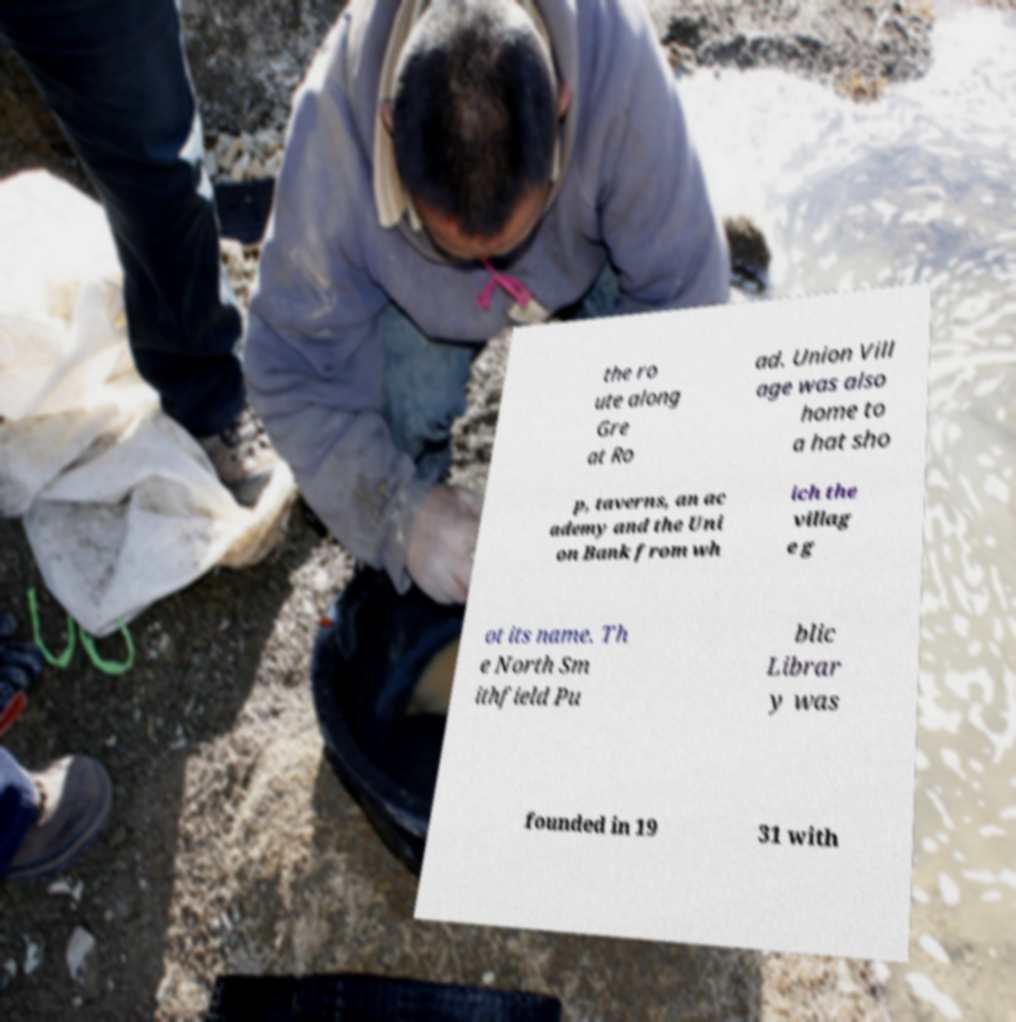Can you accurately transcribe the text from the provided image for me? the ro ute along Gre at Ro ad. Union Vill age was also home to a hat sho p, taverns, an ac ademy and the Uni on Bank from wh ich the villag e g ot its name. Th e North Sm ithfield Pu blic Librar y was founded in 19 31 with 